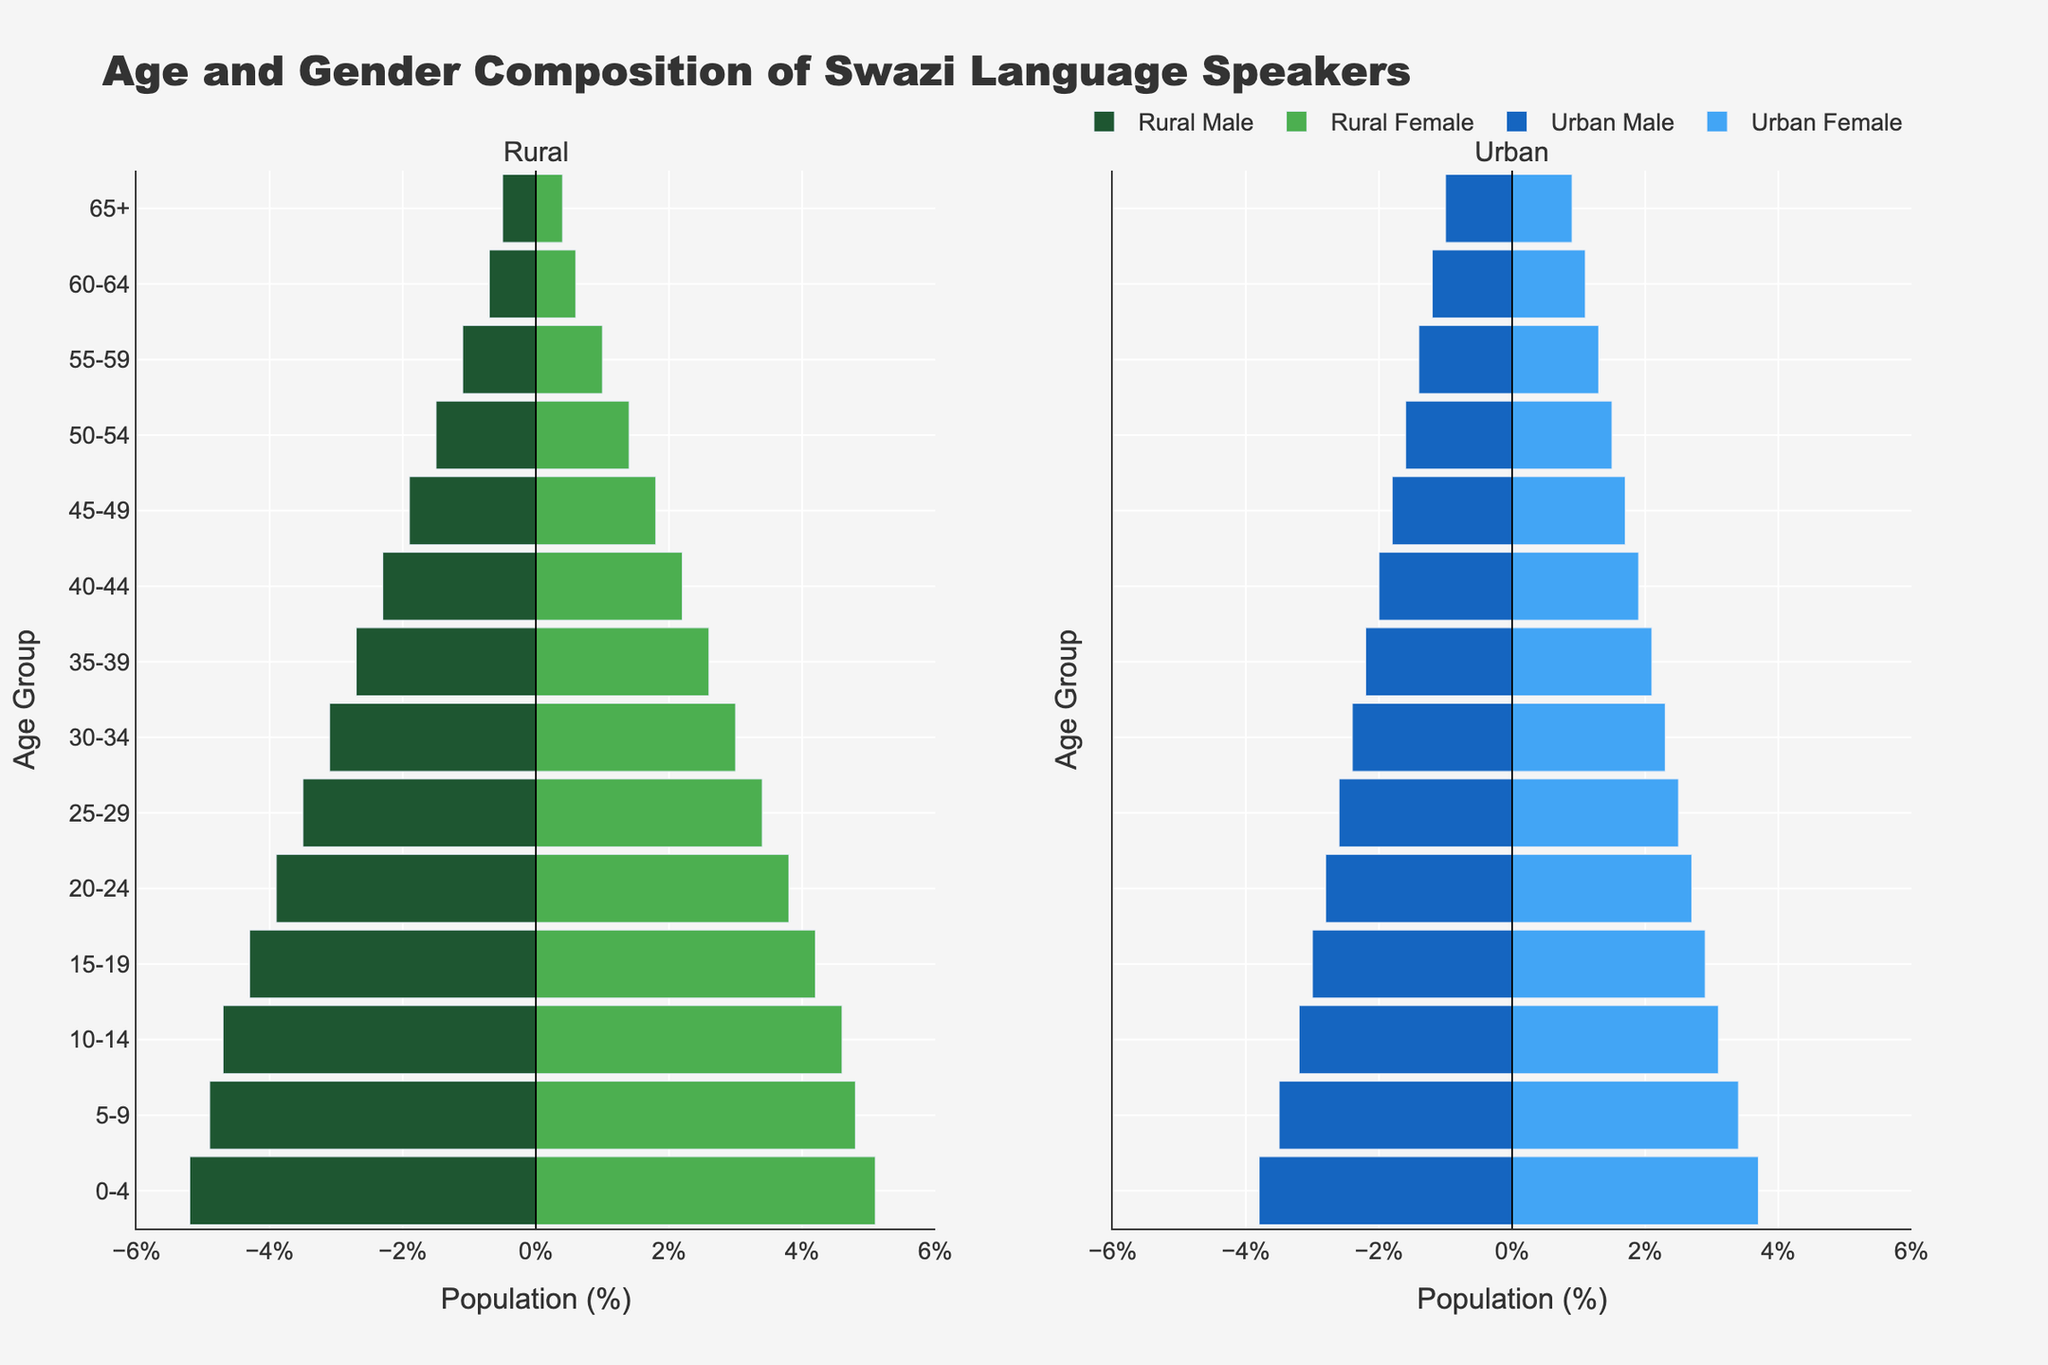What is the title of the figure? The title of the figure is usually written at the top of the plot. In this case, it is "Age and Gender Composition of Swazi Language Speakers."
Answer: Age and Gender Composition of Swazi Language Speakers What are the two main groups being compared in the figure? The two main groups are labeled at the top of each sub-plot and are "Rural" and "Urban." These represent Swazi speakers in rural and urban areas, respectively.
Answer: Rural and Urban What age group has the highest population percentage in rural areas for males? For this, we look at the left subplot labeled "Rural" and find the bar for males that extends the furthest to the left. The age group "0-4" has the longest bar for Rural Males.
Answer: 0-4 How does the population percentage of Urban Females in the 25-29 age group compare to Rural Females in the same age group? Look at the bar length for Urban Females in the 25-29 age group in the right subplot and compare it with the bar for Rural Females in the left subplot. Urban Females have a percentage of 2.5%, and Rural Females have 3.4%. Urban Females have a lower percentage than Rural Females.
Answer: Lower What is the population percentage difference between Rural Males and Females in the 0-4 age group? For the 0-4 age group, find the values for Rural Males (5.2%) and Rural Females (5.1%). Subtract the smaller value from the larger value: 5.2% - 5.1% = 0.1%.
Answer: 0.1% Which area has a higher population percentage in the age group 65+, Rural or Urban? Look at the bars for both males and females in the 65+ age group for both Rural and Urban areas. Add the values for males and females in each area. Rural: 0.5% + 0.4% = 0.9%, Urban: 1.0% + 0.9% = 1.9%. Urban has a higher population percentage in the 65+ age group.
Answer: Urban What is the trend in population percentages for Swazi language speakers as age increases in urban areas? Observing the right subplot, the bars for both Urban Males and Urban Females decrease as the age groups increase from "0-4" to "65+." This indicates a decreasing trend in population percentages as age increases.
Answer: Decreasing In the 50-54 age group, which gender has a higher population percentage in urban areas? In the right subplot, look at the bars for the 50-54 age group. The bar for Urban Males reaches 1.6%, while the bar for Urban Females reaches 1.5%. Urban Males have a higher population percentage.
Answer: Male How does the population percentage of Rural Males and Rural Females differ in the 30-34 age group? For the 30-34 age group in the left subplot, the Rural Male percentage is 3.1%, and the Rural Female percentage is 3.0%. Subtract the smaller value from the larger value: 3.1% - 3.0% = 0.1%.
Answer: 0.1% What is the overall trend in the rural population percentages for both genders as we move from younger to older age groups? Observing the whole left subplot, the bars for both Rural Males and Rural Females generally decrease as the age groups progress from "0-4" to "65+." This shows a decreasing trend in the population percentages as age increases.
Answer: Decreasing 